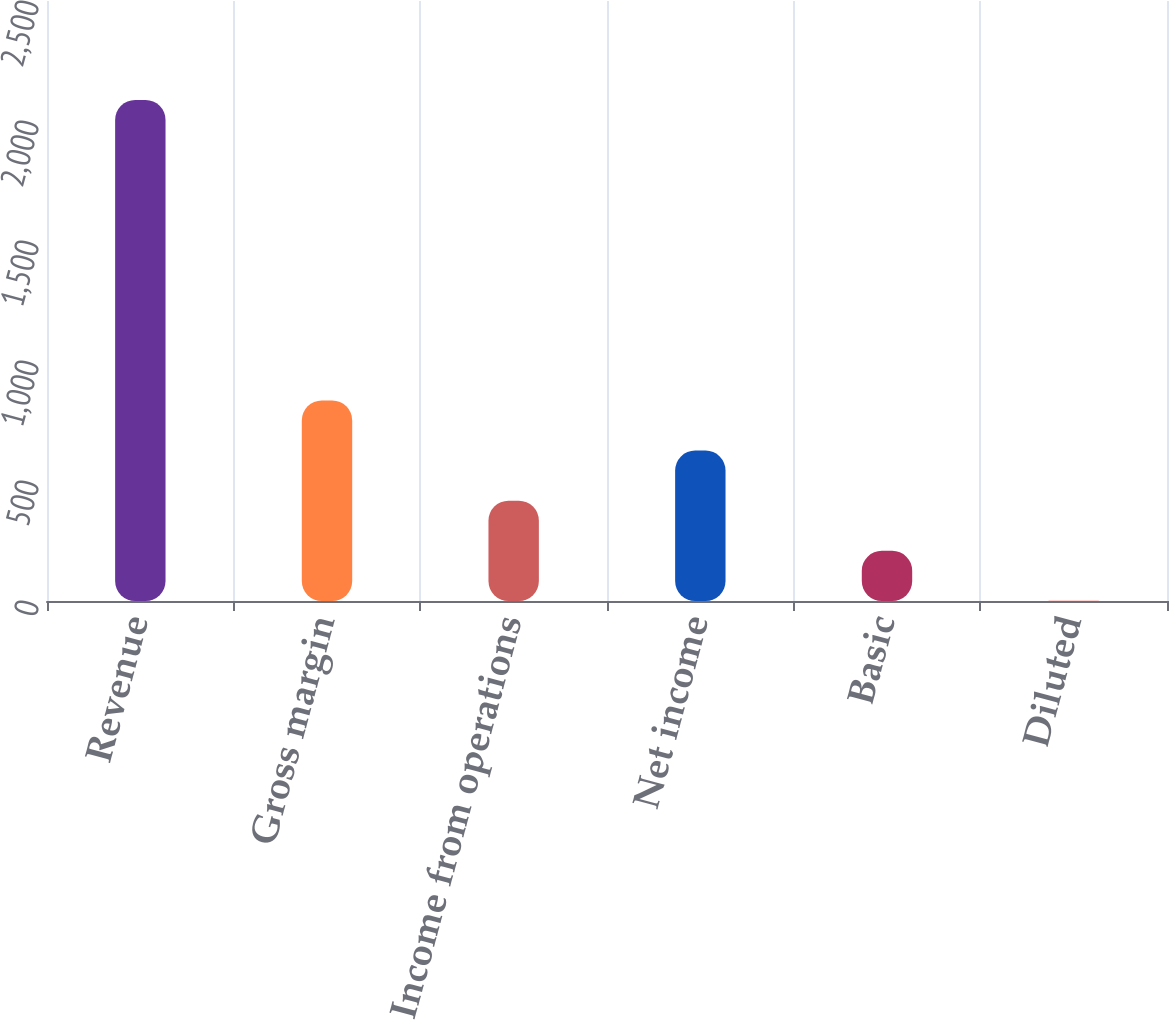Convert chart. <chart><loc_0><loc_0><loc_500><loc_500><bar_chart><fcel>Revenue<fcel>Gross margin<fcel>Income from operations<fcel>Net income<fcel>Basic<fcel>Diluted<nl><fcel>2088<fcel>835.54<fcel>418.04<fcel>626.79<fcel>209.29<fcel>0.54<nl></chart> 